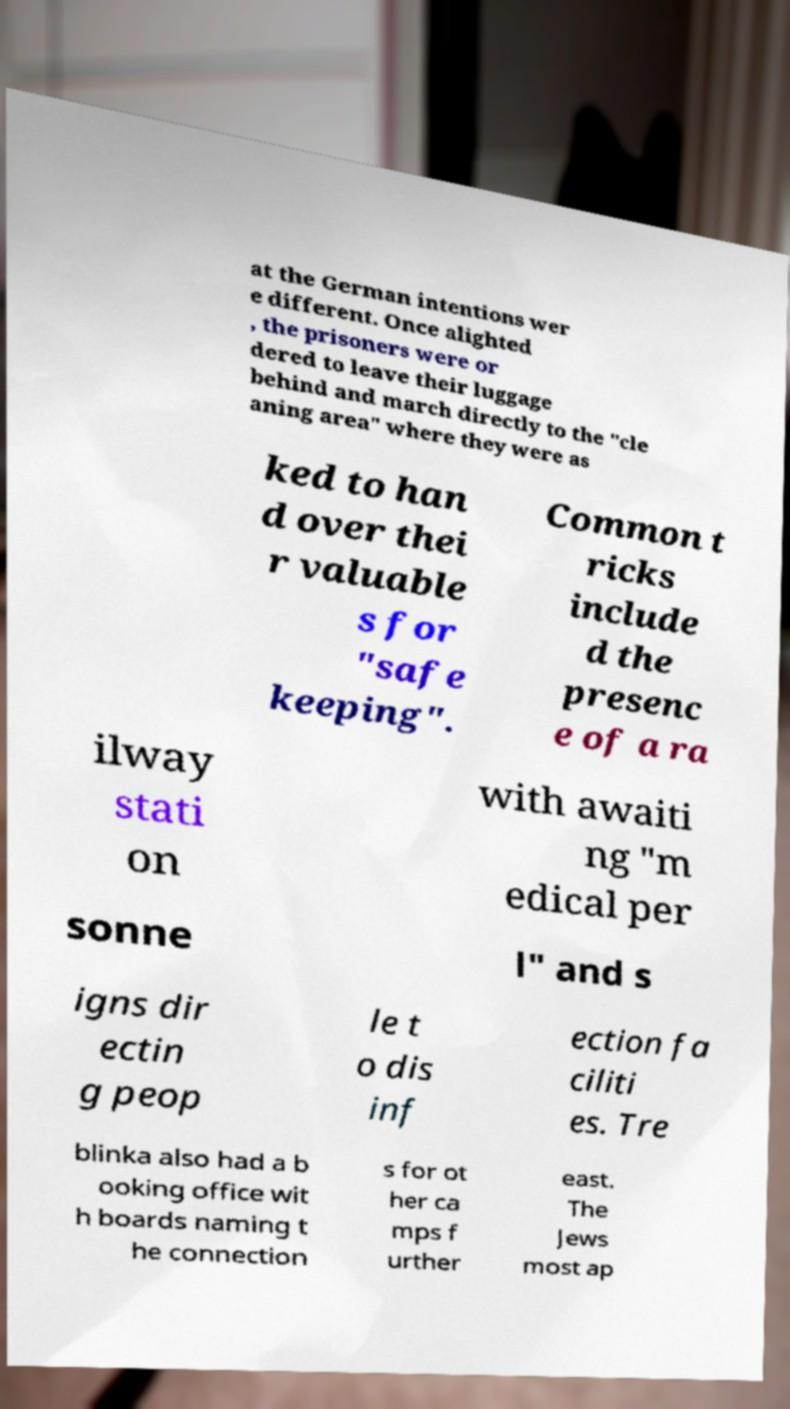For documentation purposes, I need the text within this image transcribed. Could you provide that? at the German intentions wer e different. Once alighted , the prisoners were or dered to leave their luggage behind and march directly to the "cle aning area" where they were as ked to han d over thei r valuable s for "safe keeping". Common t ricks include d the presenc e of a ra ilway stati on with awaiti ng "m edical per sonne l" and s igns dir ectin g peop le t o dis inf ection fa ciliti es. Tre blinka also had a b ooking office wit h boards naming t he connection s for ot her ca mps f urther east. The Jews most ap 